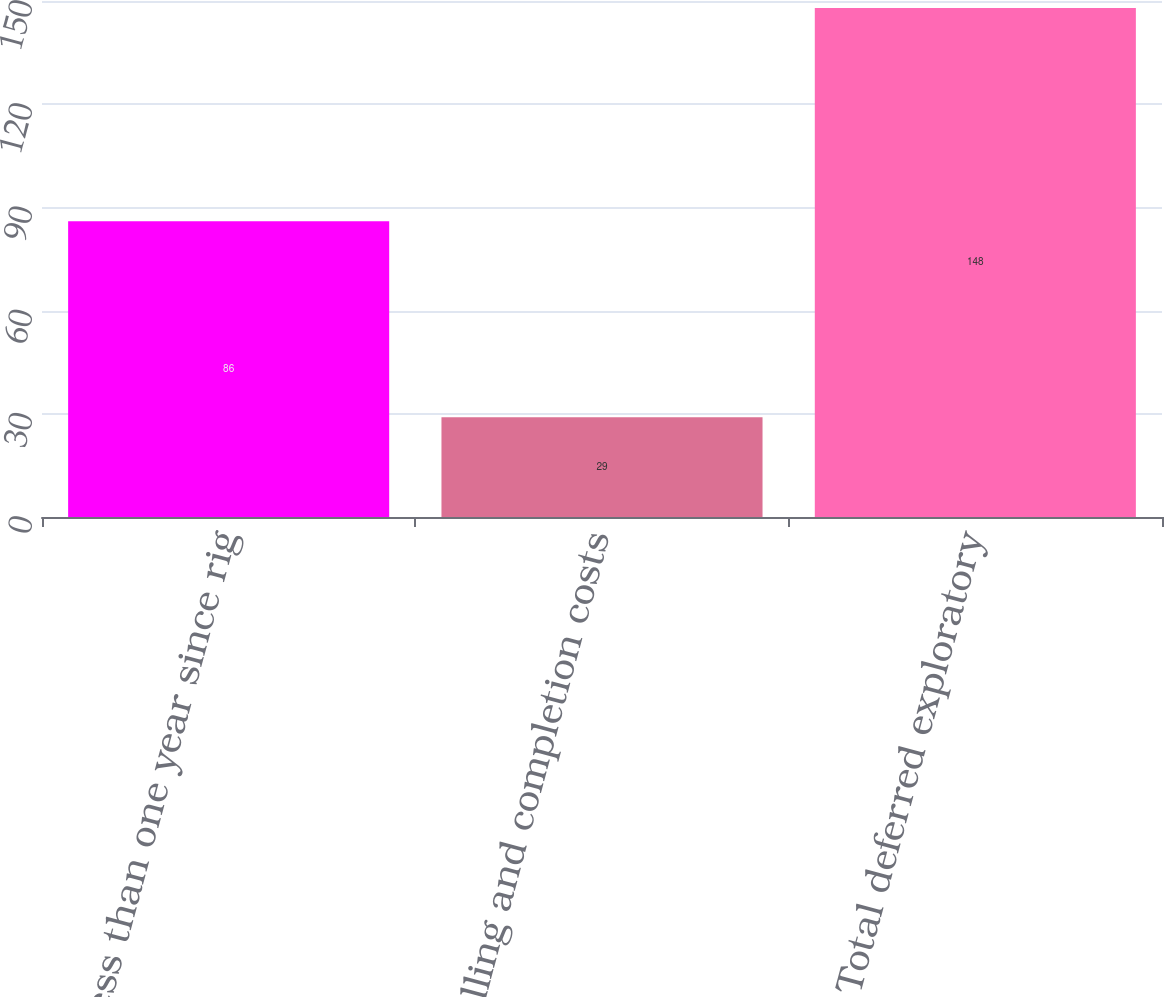Convert chart. <chart><loc_0><loc_0><loc_500><loc_500><bar_chart><fcel>Less than one year since rig<fcel>Drilling and completion costs<fcel>Total deferred exploratory<nl><fcel>86<fcel>29<fcel>148<nl></chart> 